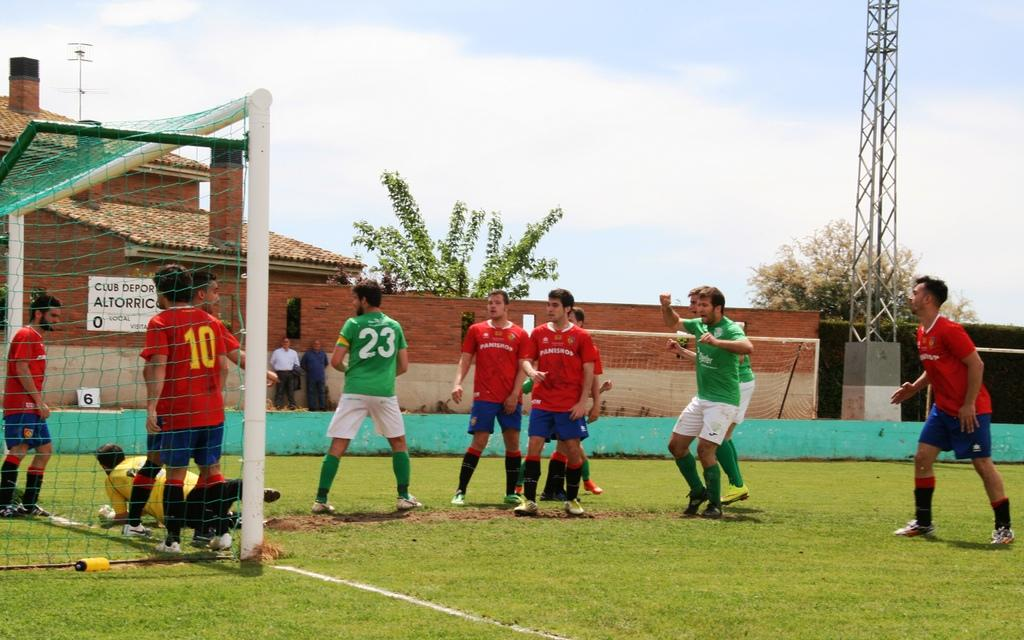<image>
Describe the image concisely. Members of the team sponsored by Panishop fight for a goal on the soccer field. 